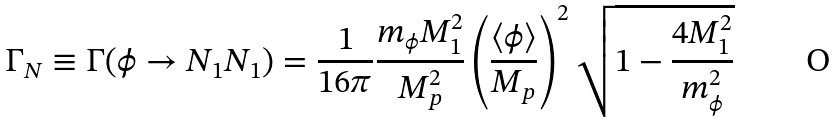<formula> <loc_0><loc_0><loc_500><loc_500>\Gamma _ { N } \equiv \Gamma ( \phi \rightarrow N _ { 1 } N _ { 1 } ) = \frac { 1 } { 1 6 \pi } \frac { m _ { \phi } M _ { 1 } ^ { 2 } } { M _ { p } ^ { 2 } } \left ( \frac { \langle \phi \rangle } { M _ { p } } \right ) ^ { 2 } \sqrt { 1 - \frac { 4 M _ { 1 } ^ { 2 } } { m _ { \phi } ^ { 2 } } }</formula> 